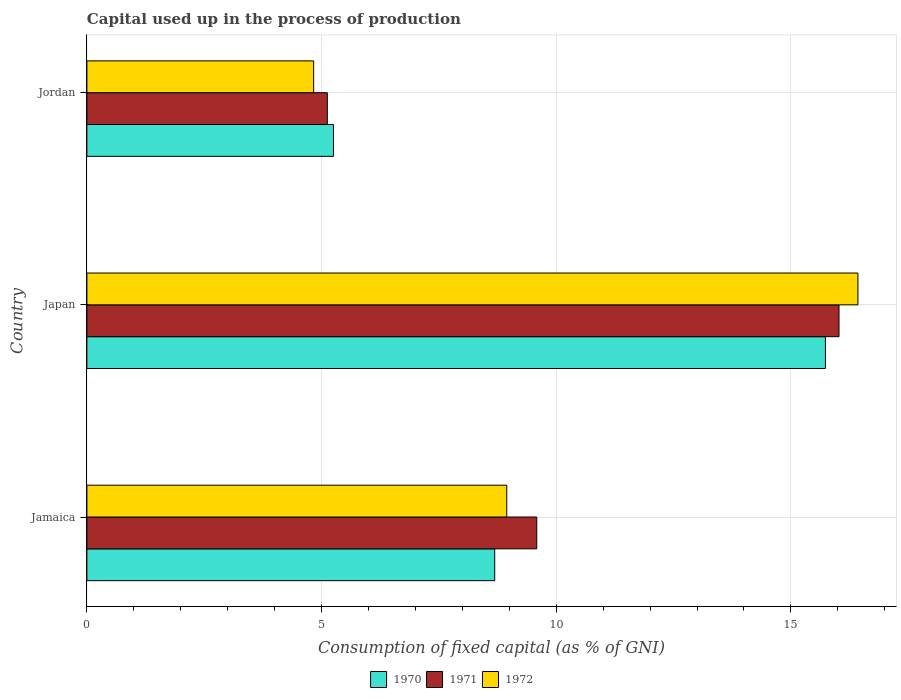How many different coloured bars are there?
Give a very brief answer. 3. Are the number of bars per tick equal to the number of legend labels?
Offer a very short reply. Yes. What is the label of the 3rd group of bars from the top?
Your answer should be compact. Jamaica. What is the capital used up in the process of production in 1972 in Jordan?
Offer a terse response. 4.83. Across all countries, what is the maximum capital used up in the process of production in 1971?
Your answer should be compact. 16.02. Across all countries, what is the minimum capital used up in the process of production in 1970?
Offer a very short reply. 5.25. In which country was the capital used up in the process of production in 1971 maximum?
Provide a short and direct response. Japan. In which country was the capital used up in the process of production in 1971 minimum?
Give a very brief answer. Jordan. What is the total capital used up in the process of production in 1971 in the graph?
Your response must be concise. 30.73. What is the difference between the capital used up in the process of production in 1970 in Jamaica and that in Jordan?
Keep it short and to the point. 3.44. What is the difference between the capital used up in the process of production in 1972 in Japan and the capital used up in the process of production in 1970 in Jamaica?
Your answer should be compact. 7.74. What is the average capital used up in the process of production in 1970 per country?
Your answer should be compact. 9.89. What is the difference between the capital used up in the process of production in 1972 and capital used up in the process of production in 1970 in Jordan?
Ensure brevity in your answer.  -0.42. In how many countries, is the capital used up in the process of production in 1972 greater than 3 %?
Your answer should be compact. 3. What is the ratio of the capital used up in the process of production in 1971 in Jamaica to that in Japan?
Offer a very short reply. 0.6. Is the capital used up in the process of production in 1970 in Jamaica less than that in Jordan?
Provide a short and direct response. No. What is the difference between the highest and the second highest capital used up in the process of production in 1970?
Your answer should be compact. 7.05. What is the difference between the highest and the lowest capital used up in the process of production in 1971?
Your answer should be very brief. 10.9. In how many countries, is the capital used up in the process of production in 1972 greater than the average capital used up in the process of production in 1972 taken over all countries?
Give a very brief answer. 1. Is the sum of the capital used up in the process of production in 1970 in Jamaica and Jordan greater than the maximum capital used up in the process of production in 1971 across all countries?
Keep it short and to the point. No. Is it the case that in every country, the sum of the capital used up in the process of production in 1971 and capital used up in the process of production in 1970 is greater than the capital used up in the process of production in 1972?
Provide a short and direct response. Yes. How many countries are there in the graph?
Your answer should be very brief. 3. What is the difference between two consecutive major ticks on the X-axis?
Provide a succinct answer. 5. Are the values on the major ticks of X-axis written in scientific E-notation?
Provide a short and direct response. No. Does the graph contain any zero values?
Keep it short and to the point. No. Does the graph contain grids?
Provide a short and direct response. Yes. How many legend labels are there?
Your answer should be very brief. 3. How are the legend labels stacked?
Offer a terse response. Horizontal. What is the title of the graph?
Ensure brevity in your answer.  Capital used up in the process of production. Does "1999" appear as one of the legend labels in the graph?
Your response must be concise. No. What is the label or title of the X-axis?
Keep it short and to the point. Consumption of fixed capital (as % of GNI). What is the label or title of the Y-axis?
Give a very brief answer. Country. What is the Consumption of fixed capital (as % of GNI) of 1970 in Jamaica?
Provide a short and direct response. 8.69. What is the Consumption of fixed capital (as % of GNI) of 1971 in Jamaica?
Provide a succinct answer. 9.58. What is the Consumption of fixed capital (as % of GNI) in 1972 in Jamaica?
Ensure brevity in your answer.  8.95. What is the Consumption of fixed capital (as % of GNI) of 1970 in Japan?
Make the answer very short. 15.74. What is the Consumption of fixed capital (as % of GNI) of 1971 in Japan?
Offer a very short reply. 16.02. What is the Consumption of fixed capital (as % of GNI) in 1972 in Japan?
Offer a very short reply. 16.43. What is the Consumption of fixed capital (as % of GNI) in 1970 in Jordan?
Give a very brief answer. 5.25. What is the Consumption of fixed capital (as % of GNI) of 1971 in Jordan?
Provide a short and direct response. 5.12. What is the Consumption of fixed capital (as % of GNI) of 1972 in Jordan?
Keep it short and to the point. 4.83. Across all countries, what is the maximum Consumption of fixed capital (as % of GNI) of 1970?
Offer a terse response. 15.74. Across all countries, what is the maximum Consumption of fixed capital (as % of GNI) of 1971?
Give a very brief answer. 16.02. Across all countries, what is the maximum Consumption of fixed capital (as % of GNI) of 1972?
Your answer should be very brief. 16.43. Across all countries, what is the minimum Consumption of fixed capital (as % of GNI) in 1970?
Provide a succinct answer. 5.25. Across all countries, what is the minimum Consumption of fixed capital (as % of GNI) in 1971?
Give a very brief answer. 5.12. Across all countries, what is the minimum Consumption of fixed capital (as % of GNI) of 1972?
Offer a very short reply. 4.83. What is the total Consumption of fixed capital (as % of GNI) in 1970 in the graph?
Provide a succinct answer. 29.68. What is the total Consumption of fixed capital (as % of GNI) of 1971 in the graph?
Your response must be concise. 30.73. What is the total Consumption of fixed capital (as % of GNI) in 1972 in the graph?
Offer a terse response. 30.21. What is the difference between the Consumption of fixed capital (as % of GNI) of 1970 in Jamaica and that in Japan?
Keep it short and to the point. -7.05. What is the difference between the Consumption of fixed capital (as % of GNI) of 1971 in Jamaica and that in Japan?
Your answer should be very brief. -6.44. What is the difference between the Consumption of fixed capital (as % of GNI) in 1972 in Jamaica and that in Japan?
Make the answer very short. -7.48. What is the difference between the Consumption of fixed capital (as % of GNI) of 1970 in Jamaica and that in Jordan?
Ensure brevity in your answer.  3.44. What is the difference between the Consumption of fixed capital (as % of GNI) of 1971 in Jamaica and that in Jordan?
Your answer should be compact. 4.46. What is the difference between the Consumption of fixed capital (as % of GNI) in 1972 in Jamaica and that in Jordan?
Offer a very short reply. 4.11. What is the difference between the Consumption of fixed capital (as % of GNI) in 1970 in Japan and that in Jordan?
Your answer should be very brief. 10.48. What is the difference between the Consumption of fixed capital (as % of GNI) in 1971 in Japan and that in Jordan?
Your answer should be very brief. 10.9. What is the difference between the Consumption of fixed capital (as % of GNI) in 1972 in Japan and that in Jordan?
Your response must be concise. 11.6. What is the difference between the Consumption of fixed capital (as % of GNI) of 1970 in Jamaica and the Consumption of fixed capital (as % of GNI) of 1971 in Japan?
Make the answer very short. -7.34. What is the difference between the Consumption of fixed capital (as % of GNI) in 1970 in Jamaica and the Consumption of fixed capital (as % of GNI) in 1972 in Japan?
Your answer should be compact. -7.74. What is the difference between the Consumption of fixed capital (as % of GNI) in 1971 in Jamaica and the Consumption of fixed capital (as % of GNI) in 1972 in Japan?
Offer a very short reply. -6.84. What is the difference between the Consumption of fixed capital (as % of GNI) of 1970 in Jamaica and the Consumption of fixed capital (as % of GNI) of 1971 in Jordan?
Provide a short and direct response. 3.57. What is the difference between the Consumption of fixed capital (as % of GNI) in 1970 in Jamaica and the Consumption of fixed capital (as % of GNI) in 1972 in Jordan?
Give a very brief answer. 3.86. What is the difference between the Consumption of fixed capital (as % of GNI) of 1971 in Jamaica and the Consumption of fixed capital (as % of GNI) of 1972 in Jordan?
Make the answer very short. 4.75. What is the difference between the Consumption of fixed capital (as % of GNI) in 1970 in Japan and the Consumption of fixed capital (as % of GNI) in 1971 in Jordan?
Give a very brief answer. 10.61. What is the difference between the Consumption of fixed capital (as % of GNI) in 1970 in Japan and the Consumption of fixed capital (as % of GNI) in 1972 in Jordan?
Offer a very short reply. 10.9. What is the difference between the Consumption of fixed capital (as % of GNI) in 1971 in Japan and the Consumption of fixed capital (as % of GNI) in 1972 in Jordan?
Make the answer very short. 11.19. What is the average Consumption of fixed capital (as % of GNI) in 1970 per country?
Your response must be concise. 9.89. What is the average Consumption of fixed capital (as % of GNI) in 1971 per country?
Keep it short and to the point. 10.24. What is the average Consumption of fixed capital (as % of GNI) in 1972 per country?
Give a very brief answer. 10.07. What is the difference between the Consumption of fixed capital (as % of GNI) in 1970 and Consumption of fixed capital (as % of GNI) in 1971 in Jamaica?
Provide a short and direct response. -0.9. What is the difference between the Consumption of fixed capital (as % of GNI) of 1970 and Consumption of fixed capital (as % of GNI) of 1972 in Jamaica?
Ensure brevity in your answer.  -0.26. What is the difference between the Consumption of fixed capital (as % of GNI) of 1971 and Consumption of fixed capital (as % of GNI) of 1972 in Jamaica?
Provide a succinct answer. 0.64. What is the difference between the Consumption of fixed capital (as % of GNI) in 1970 and Consumption of fixed capital (as % of GNI) in 1971 in Japan?
Offer a very short reply. -0.29. What is the difference between the Consumption of fixed capital (as % of GNI) of 1970 and Consumption of fixed capital (as % of GNI) of 1972 in Japan?
Provide a short and direct response. -0.69. What is the difference between the Consumption of fixed capital (as % of GNI) in 1971 and Consumption of fixed capital (as % of GNI) in 1972 in Japan?
Your answer should be compact. -0.4. What is the difference between the Consumption of fixed capital (as % of GNI) of 1970 and Consumption of fixed capital (as % of GNI) of 1971 in Jordan?
Provide a succinct answer. 0.13. What is the difference between the Consumption of fixed capital (as % of GNI) of 1970 and Consumption of fixed capital (as % of GNI) of 1972 in Jordan?
Keep it short and to the point. 0.42. What is the difference between the Consumption of fixed capital (as % of GNI) in 1971 and Consumption of fixed capital (as % of GNI) in 1972 in Jordan?
Offer a terse response. 0.29. What is the ratio of the Consumption of fixed capital (as % of GNI) in 1970 in Jamaica to that in Japan?
Make the answer very short. 0.55. What is the ratio of the Consumption of fixed capital (as % of GNI) of 1971 in Jamaica to that in Japan?
Keep it short and to the point. 0.6. What is the ratio of the Consumption of fixed capital (as % of GNI) of 1972 in Jamaica to that in Japan?
Your answer should be compact. 0.54. What is the ratio of the Consumption of fixed capital (as % of GNI) of 1970 in Jamaica to that in Jordan?
Provide a short and direct response. 1.65. What is the ratio of the Consumption of fixed capital (as % of GNI) in 1971 in Jamaica to that in Jordan?
Your answer should be compact. 1.87. What is the ratio of the Consumption of fixed capital (as % of GNI) of 1972 in Jamaica to that in Jordan?
Offer a very short reply. 1.85. What is the ratio of the Consumption of fixed capital (as % of GNI) of 1970 in Japan to that in Jordan?
Give a very brief answer. 3. What is the ratio of the Consumption of fixed capital (as % of GNI) of 1971 in Japan to that in Jordan?
Give a very brief answer. 3.13. What is the ratio of the Consumption of fixed capital (as % of GNI) in 1972 in Japan to that in Jordan?
Give a very brief answer. 3.4. What is the difference between the highest and the second highest Consumption of fixed capital (as % of GNI) of 1970?
Make the answer very short. 7.05. What is the difference between the highest and the second highest Consumption of fixed capital (as % of GNI) in 1971?
Offer a terse response. 6.44. What is the difference between the highest and the second highest Consumption of fixed capital (as % of GNI) of 1972?
Offer a very short reply. 7.48. What is the difference between the highest and the lowest Consumption of fixed capital (as % of GNI) of 1970?
Provide a short and direct response. 10.48. What is the difference between the highest and the lowest Consumption of fixed capital (as % of GNI) of 1971?
Your response must be concise. 10.9. What is the difference between the highest and the lowest Consumption of fixed capital (as % of GNI) of 1972?
Your answer should be compact. 11.6. 